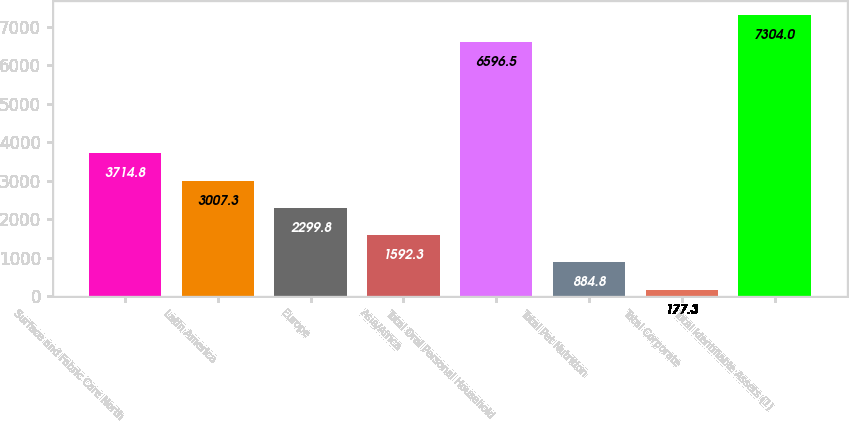Convert chart to OTSL. <chart><loc_0><loc_0><loc_500><loc_500><bar_chart><fcel>Surface and Fabric Care North<fcel>Latin America<fcel>Europe<fcel>Asia/Africa<fcel>Total Oral Personal Household<fcel>Total Pet Nutrition<fcel>Total Corporate<fcel>Total Identifiable Assets (1)<nl><fcel>3714.8<fcel>3007.3<fcel>2299.8<fcel>1592.3<fcel>6596.5<fcel>884.8<fcel>177.3<fcel>7304<nl></chart> 